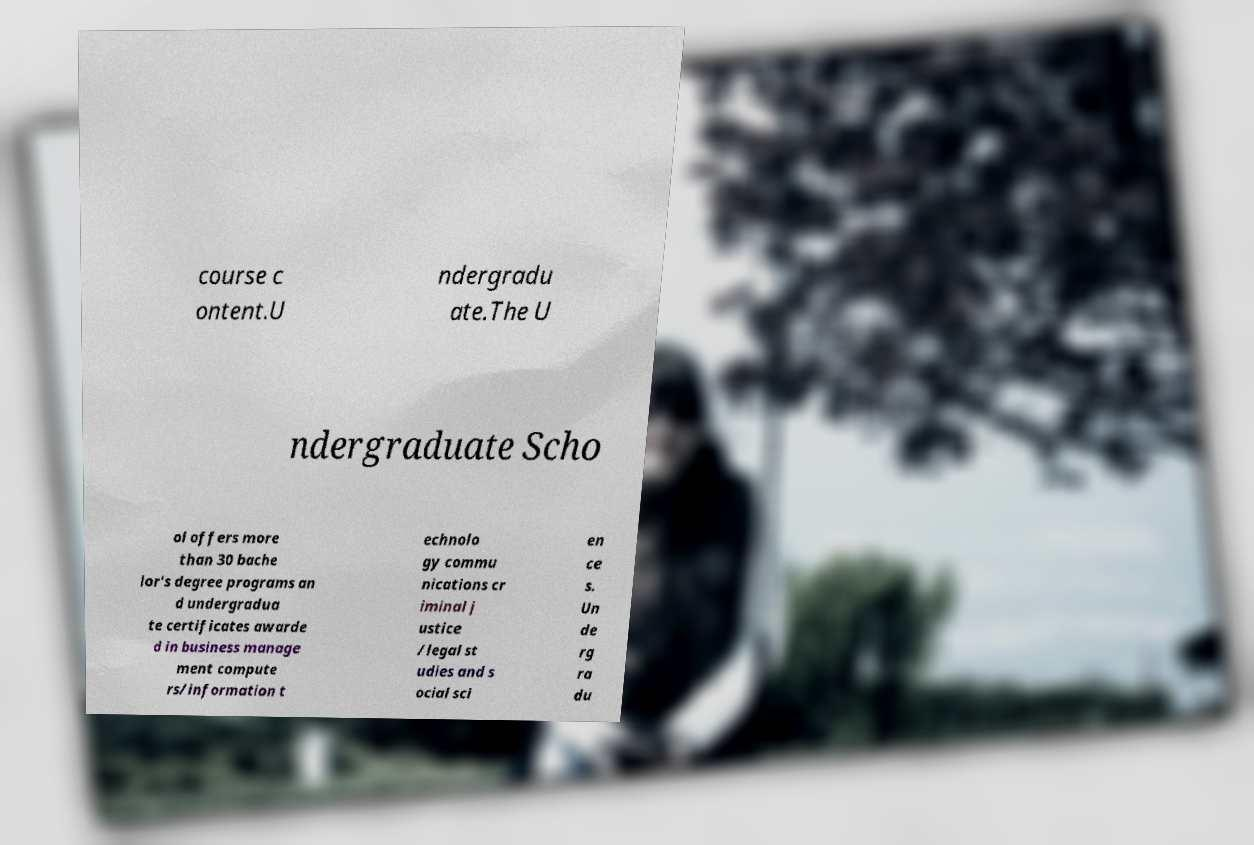There's text embedded in this image that I need extracted. Can you transcribe it verbatim? course c ontent.U ndergradu ate.The U ndergraduate Scho ol offers more than 30 bache lor's degree programs an d undergradua te certificates awarde d in business manage ment compute rs/information t echnolo gy commu nications cr iminal j ustice /legal st udies and s ocial sci en ce s. Un de rg ra du 